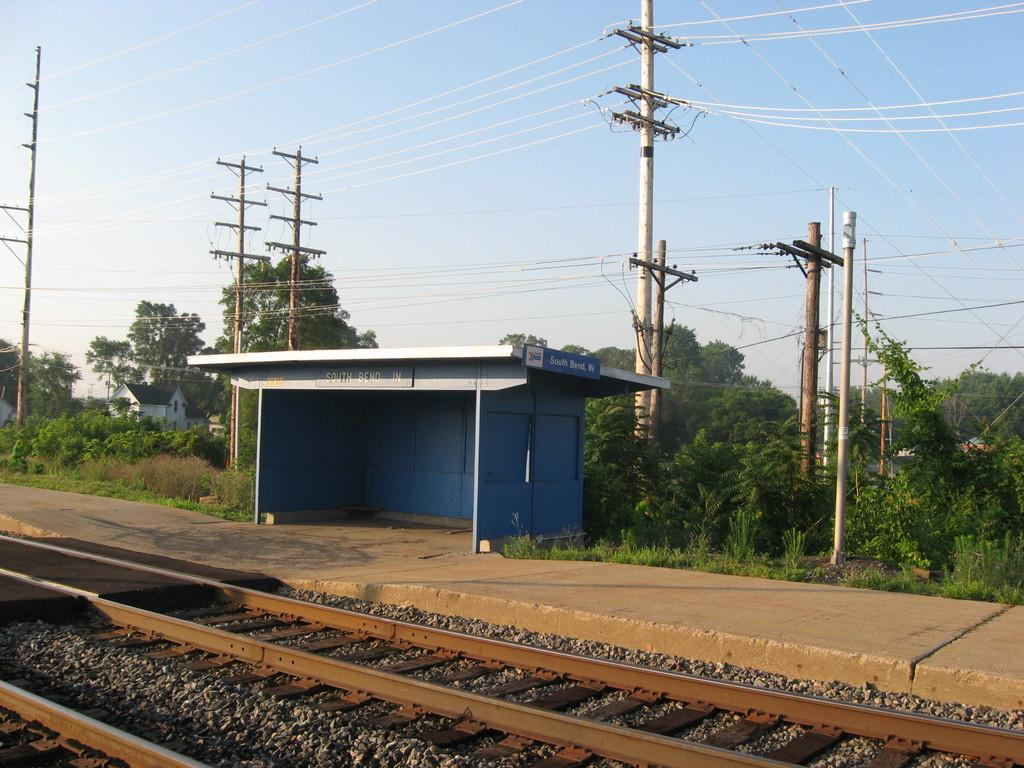What type of structure is present in the picture? There is a railway station in the picture. What is located near the railway station? There are railway tracks in the picture. What else can be seen in the picture besides the railway station and tracks? There are poles and wires, trees, and the sky visible in the background of the picture. What type of test is being conducted on the queen in the picture? There is no queen or test present in the picture; it features a railway station, tracks, poles and wires, trees, and the sky. What does the railway station smell like in the picture? The picture does not provide any information about the smell of the railway station or any other element in the image. 